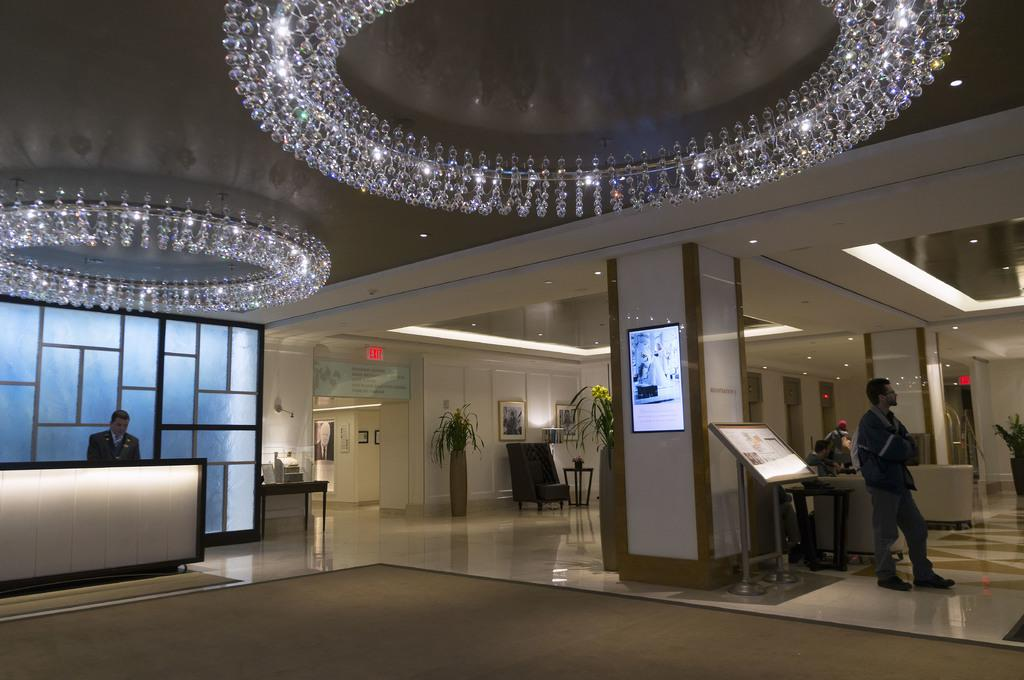What type of location is depicted in the image? The image is an inside picture of a building. What can be seen on the ceiling in the image? There is a ceiling with lights in the image. Is there anyone visible in the image? Yes, there is a person standing at the right side of the image. What type of vegetation is present in the image? There are plants in the image. How many basins are visible in the image? There are no basins present in the image. What type of system is being used by the frogs in the image? There are no frogs present in the image, so it is not possible to determine what type of system they might be using. 